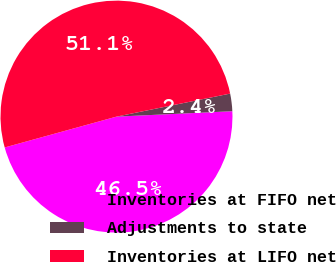<chart> <loc_0><loc_0><loc_500><loc_500><pie_chart><fcel>Inventories at FIFO net<fcel>Adjustments to state<fcel>Inventories at LIFO net<nl><fcel>46.46%<fcel>2.44%<fcel>51.1%<nl></chart> 